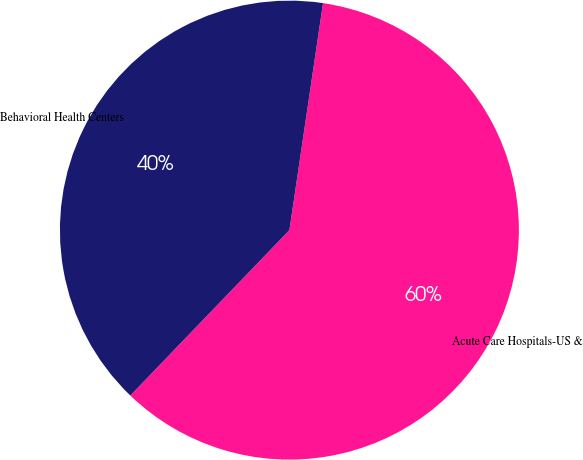Convert chart to OTSL. <chart><loc_0><loc_0><loc_500><loc_500><pie_chart><fcel>Acute Care Hospitals-US &<fcel>Behavioral Health Centers<nl><fcel>59.85%<fcel>40.15%<nl></chart> 